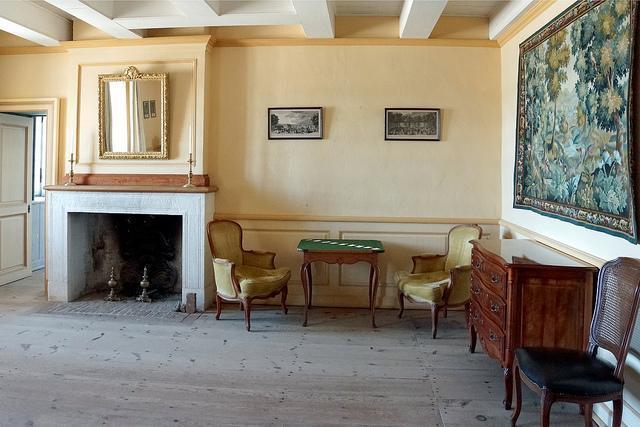Where are the candles placed in the room?
Pick the right solution, then justify: 'Answer: answer
Rationale: rationale.'
Options: Mantle, table, dresser, floor. Answer: mantle.
Rationale: The candles are on the mantle. 